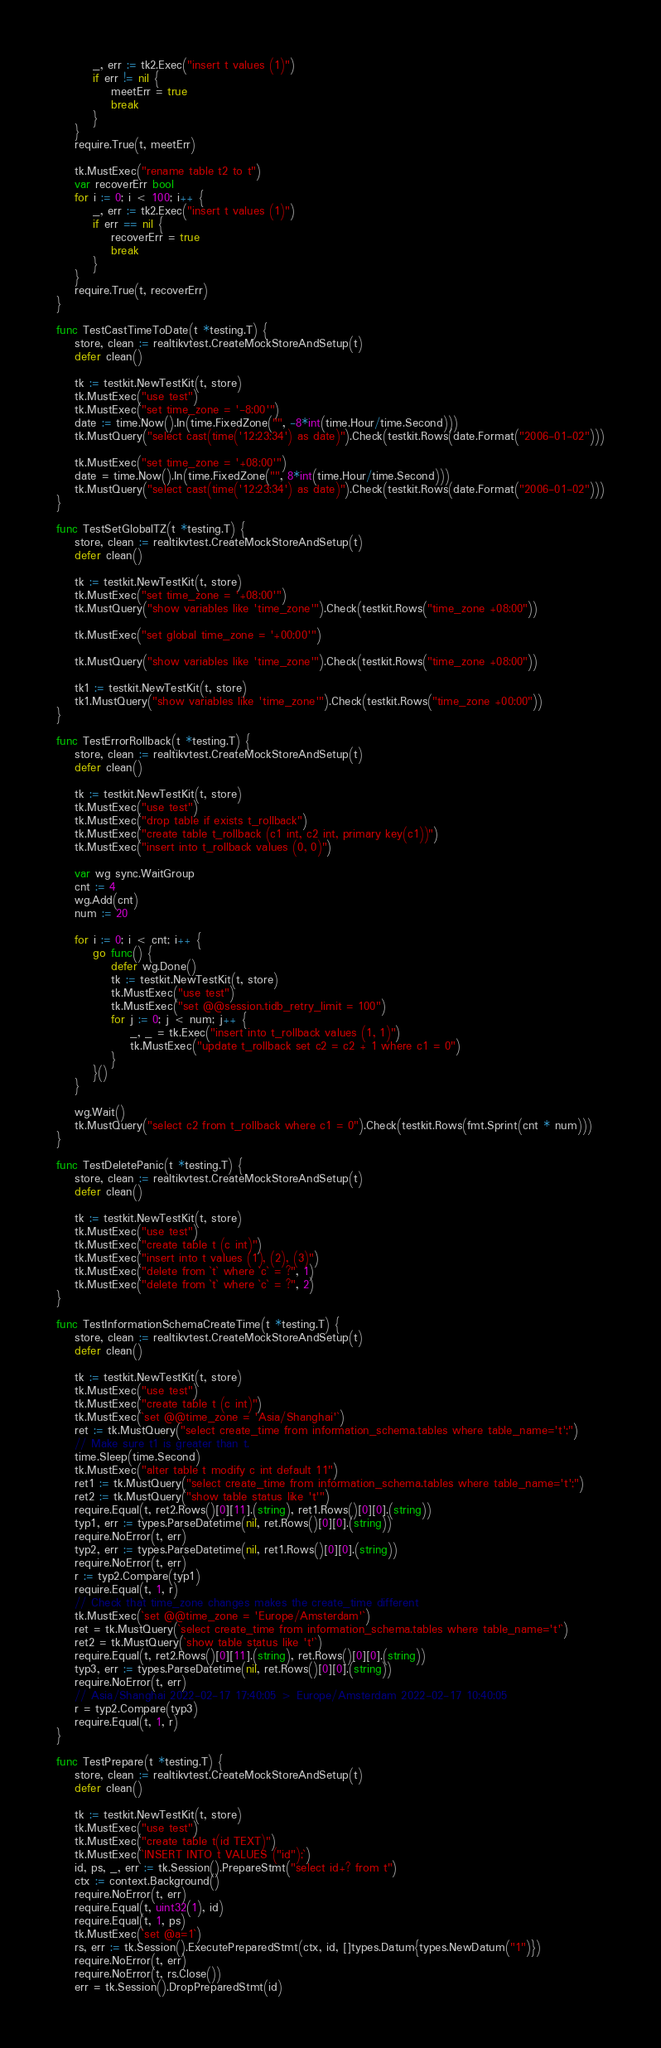Convert code to text. <code><loc_0><loc_0><loc_500><loc_500><_Go_>		_, err := tk2.Exec("insert t values (1)")
		if err != nil {
			meetErr = true
			break
		}
	}
	require.True(t, meetErr)

	tk.MustExec("rename table t2 to t")
	var recoverErr bool
	for i := 0; i < 100; i++ {
		_, err := tk2.Exec("insert t values (1)")
		if err == nil {
			recoverErr = true
			break
		}
	}
	require.True(t, recoverErr)
}

func TestCastTimeToDate(t *testing.T) {
	store, clean := realtikvtest.CreateMockStoreAndSetup(t)
	defer clean()

	tk := testkit.NewTestKit(t, store)
	tk.MustExec("use test")
	tk.MustExec("set time_zone = '-8:00'")
	date := time.Now().In(time.FixedZone("", -8*int(time.Hour/time.Second)))
	tk.MustQuery("select cast(time('12:23:34') as date)").Check(testkit.Rows(date.Format("2006-01-02")))

	tk.MustExec("set time_zone = '+08:00'")
	date = time.Now().In(time.FixedZone("", 8*int(time.Hour/time.Second)))
	tk.MustQuery("select cast(time('12:23:34') as date)").Check(testkit.Rows(date.Format("2006-01-02")))
}

func TestSetGlobalTZ(t *testing.T) {
	store, clean := realtikvtest.CreateMockStoreAndSetup(t)
	defer clean()

	tk := testkit.NewTestKit(t, store)
	tk.MustExec("set time_zone = '+08:00'")
	tk.MustQuery("show variables like 'time_zone'").Check(testkit.Rows("time_zone +08:00"))

	tk.MustExec("set global time_zone = '+00:00'")

	tk.MustQuery("show variables like 'time_zone'").Check(testkit.Rows("time_zone +08:00"))

	tk1 := testkit.NewTestKit(t, store)
	tk1.MustQuery("show variables like 'time_zone'").Check(testkit.Rows("time_zone +00:00"))
}

func TestErrorRollback(t *testing.T) {
	store, clean := realtikvtest.CreateMockStoreAndSetup(t)
	defer clean()

	tk := testkit.NewTestKit(t, store)
	tk.MustExec("use test")
	tk.MustExec("drop table if exists t_rollback")
	tk.MustExec("create table t_rollback (c1 int, c2 int, primary key(c1))")
	tk.MustExec("insert into t_rollback values (0, 0)")

	var wg sync.WaitGroup
	cnt := 4
	wg.Add(cnt)
	num := 20

	for i := 0; i < cnt; i++ {
		go func() {
			defer wg.Done()
			tk := testkit.NewTestKit(t, store)
			tk.MustExec("use test")
			tk.MustExec("set @@session.tidb_retry_limit = 100")
			for j := 0; j < num; j++ {
				_, _ = tk.Exec("insert into t_rollback values (1, 1)")
				tk.MustExec("update t_rollback set c2 = c2 + 1 where c1 = 0")
			}
		}()
	}

	wg.Wait()
	tk.MustQuery("select c2 from t_rollback where c1 = 0").Check(testkit.Rows(fmt.Sprint(cnt * num)))
}

func TestDeletePanic(t *testing.T) {
	store, clean := realtikvtest.CreateMockStoreAndSetup(t)
	defer clean()

	tk := testkit.NewTestKit(t, store)
	tk.MustExec("use test")
	tk.MustExec("create table t (c int)")
	tk.MustExec("insert into t values (1), (2), (3)")
	tk.MustExec("delete from `t` where `c` = ?", 1)
	tk.MustExec("delete from `t` where `c` = ?", 2)
}

func TestInformationSchemaCreateTime(t *testing.T) {
	store, clean := realtikvtest.CreateMockStoreAndSetup(t)
	defer clean()

	tk := testkit.NewTestKit(t, store)
	tk.MustExec("use test")
	tk.MustExec("create table t (c int)")
	tk.MustExec(`set @@time_zone = 'Asia/Shanghai'`)
	ret := tk.MustQuery("select create_time from information_schema.tables where table_name='t';")
	// Make sure t1 is greater than t.
	time.Sleep(time.Second)
	tk.MustExec("alter table t modify c int default 11")
	ret1 := tk.MustQuery("select create_time from information_schema.tables where table_name='t';")
	ret2 := tk.MustQuery("show table status like 't'")
	require.Equal(t, ret2.Rows()[0][11].(string), ret1.Rows()[0][0].(string))
	typ1, err := types.ParseDatetime(nil, ret.Rows()[0][0].(string))
	require.NoError(t, err)
	typ2, err := types.ParseDatetime(nil, ret1.Rows()[0][0].(string))
	require.NoError(t, err)
	r := typ2.Compare(typ1)
	require.Equal(t, 1, r)
	// Check that time_zone changes makes the create_time different
	tk.MustExec(`set @@time_zone = 'Europe/Amsterdam'`)
	ret = tk.MustQuery(`select create_time from information_schema.tables where table_name='t'`)
	ret2 = tk.MustQuery(`show table status like 't'`)
	require.Equal(t, ret2.Rows()[0][11].(string), ret.Rows()[0][0].(string))
	typ3, err := types.ParseDatetime(nil, ret.Rows()[0][0].(string))
	require.NoError(t, err)
	// Asia/Shanghai 2022-02-17 17:40:05 > Europe/Amsterdam 2022-02-17 10:40:05
	r = typ2.Compare(typ3)
	require.Equal(t, 1, r)
}

func TestPrepare(t *testing.T) {
	store, clean := realtikvtest.CreateMockStoreAndSetup(t)
	defer clean()

	tk := testkit.NewTestKit(t, store)
	tk.MustExec("use test")
	tk.MustExec("create table t(id TEXT)")
	tk.MustExec(`INSERT INTO t VALUES ("id");`)
	id, ps, _, err := tk.Session().PrepareStmt("select id+? from t")
	ctx := context.Background()
	require.NoError(t, err)
	require.Equal(t, uint32(1), id)
	require.Equal(t, 1, ps)
	tk.MustExec(`set @a=1`)
	rs, err := tk.Session().ExecutePreparedStmt(ctx, id, []types.Datum{types.NewDatum("1")})
	require.NoError(t, err)
	require.NoError(t, rs.Close())
	err = tk.Session().DropPreparedStmt(id)</code> 